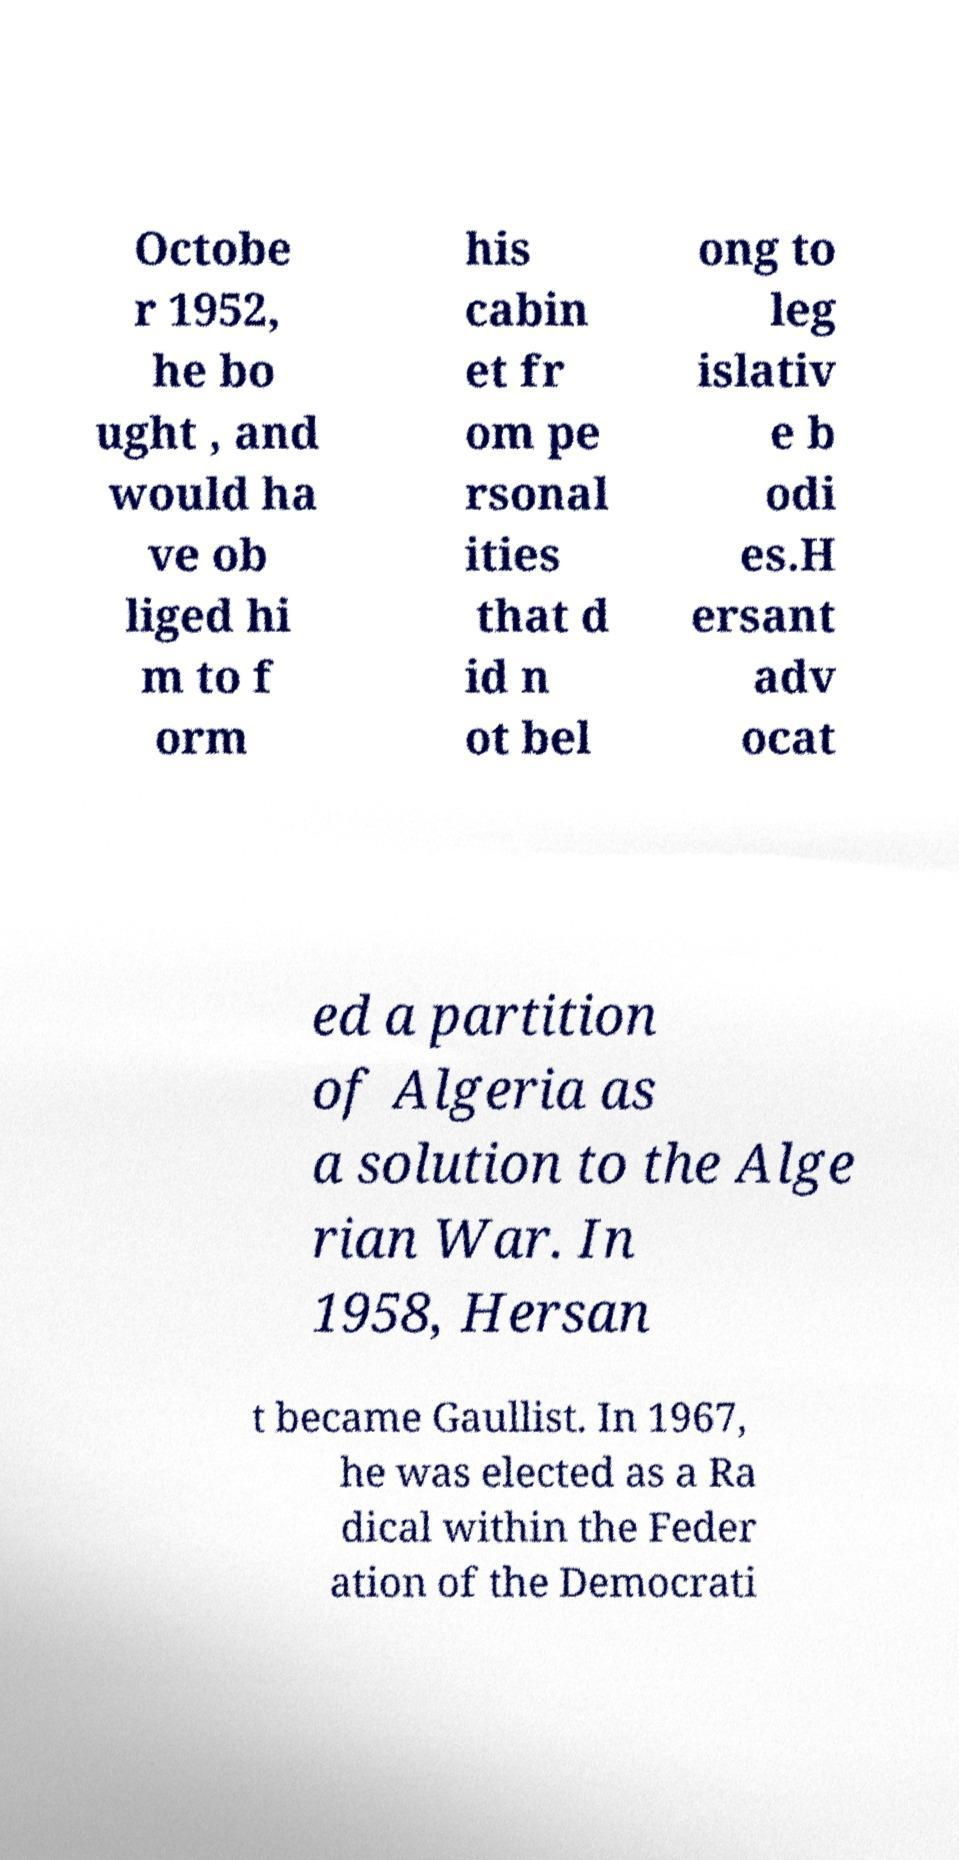Can you read and provide the text displayed in the image?This photo seems to have some interesting text. Can you extract and type it out for me? Octobe r 1952, he bo ught , and would ha ve ob liged hi m to f orm his cabin et fr om pe rsonal ities that d id n ot bel ong to leg islativ e b odi es.H ersant adv ocat ed a partition of Algeria as a solution to the Alge rian War. In 1958, Hersan t became Gaullist. In 1967, he was elected as a Ra dical within the Feder ation of the Democrati 